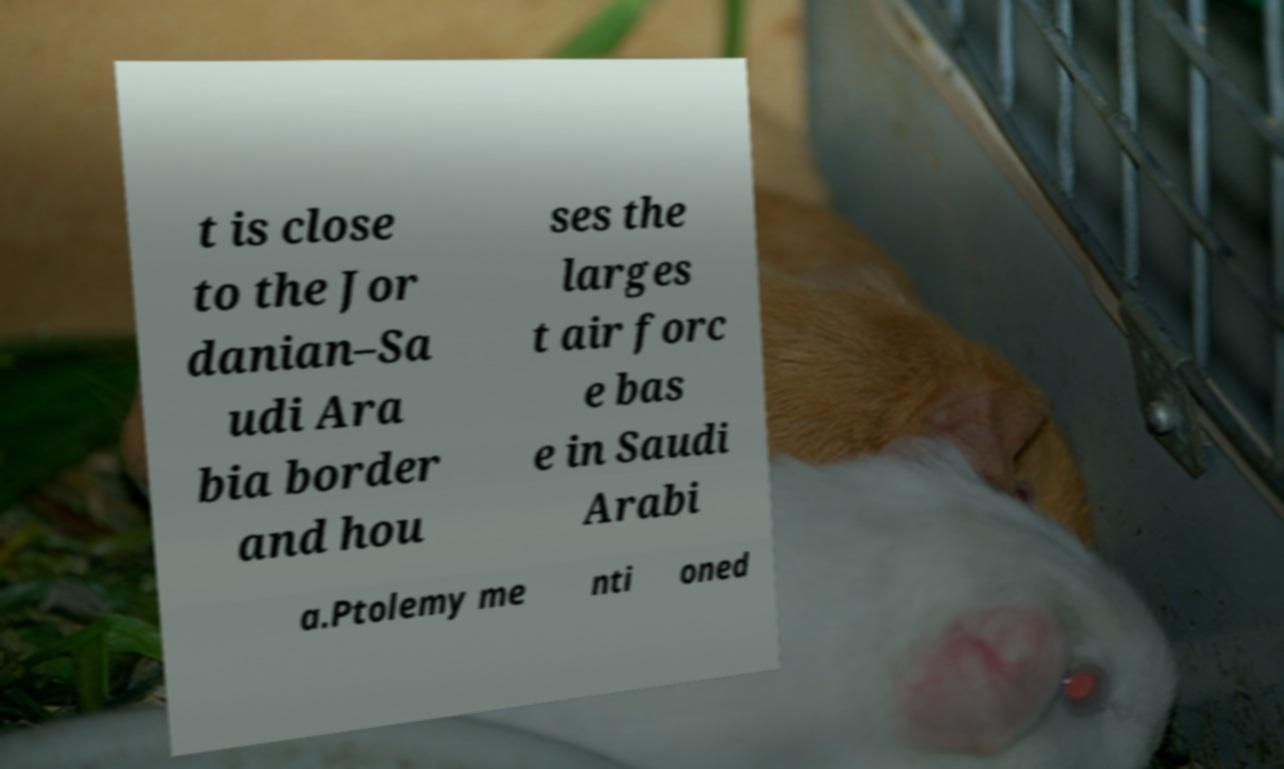For documentation purposes, I need the text within this image transcribed. Could you provide that? t is close to the Jor danian–Sa udi Ara bia border and hou ses the larges t air forc e bas e in Saudi Arabi a.Ptolemy me nti oned 